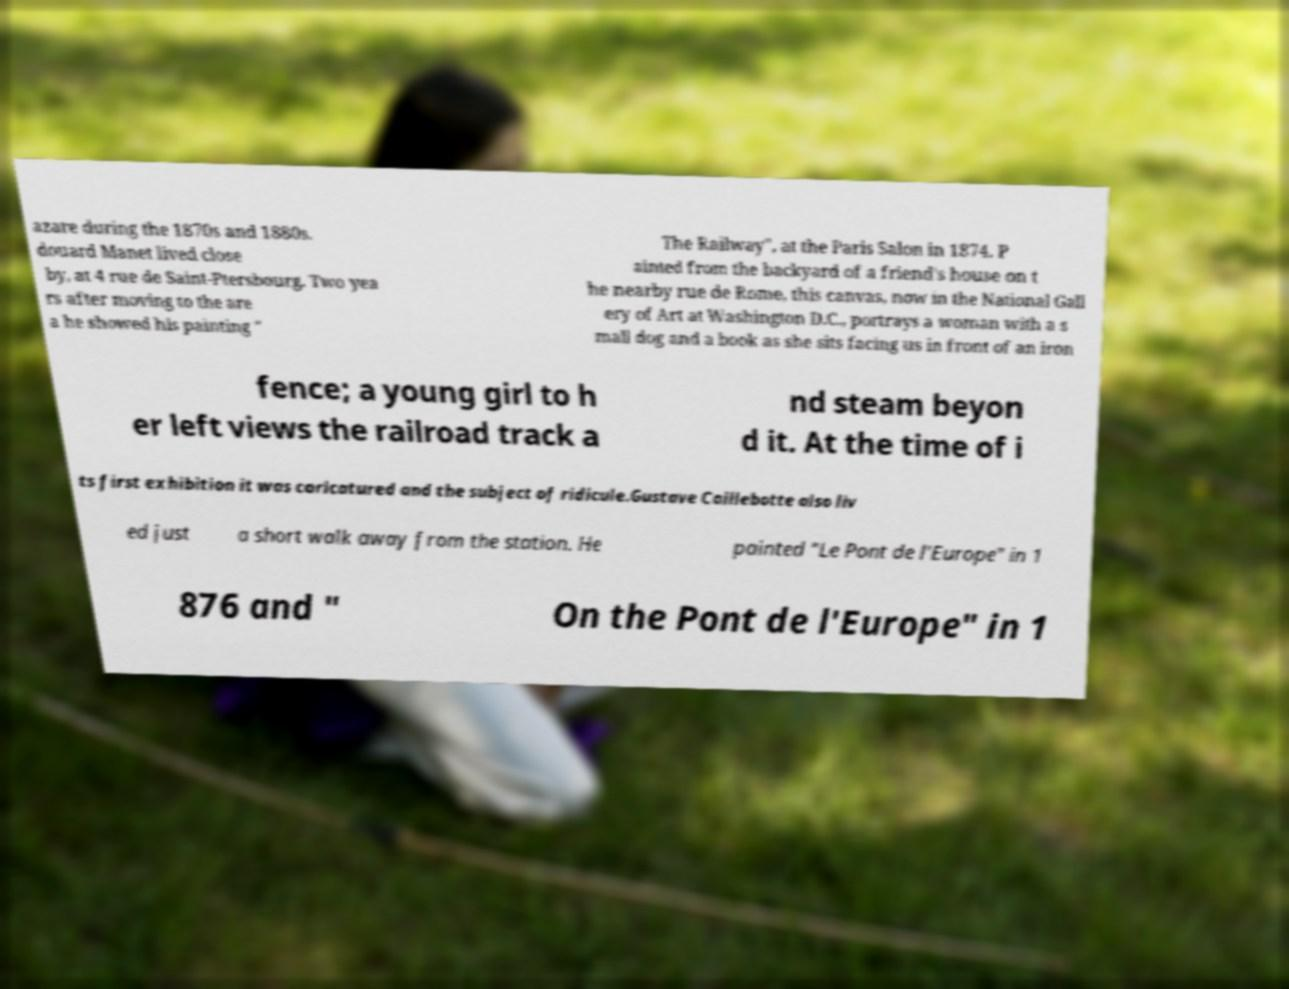There's text embedded in this image that I need extracted. Can you transcribe it verbatim? azare during the 1870s and 1880s. douard Manet lived close by, at 4 rue de Saint-Ptersbourg. Two yea rs after moving to the are a he showed his painting " The Railway", at the Paris Salon in 1874. P ainted from the backyard of a friend's house on t he nearby rue de Rome, this canvas, now in the National Gall ery of Art at Washington D.C., portrays a woman with a s mall dog and a book as she sits facing us in front of an iron fence; a young girl to h er left views the railroad track a nd steam beyon d it. At the time of i ts first exhibition it was caricatured and the subject of ridicule.Gustave Caillebotte also liv ed just a short walk away from the station. He painted "Le Pont de l’Europe" in 1 876 and " On the Pont de l'Europe" in 1 